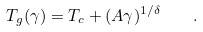Convert formula to latex. <formula><loc_0><loc_0><loc_500><loc_500>T _ { g } ( \gamma ) = T _ { c } + ( A \gamma ) ^ { 1 / \delta } \quad .</formula> 